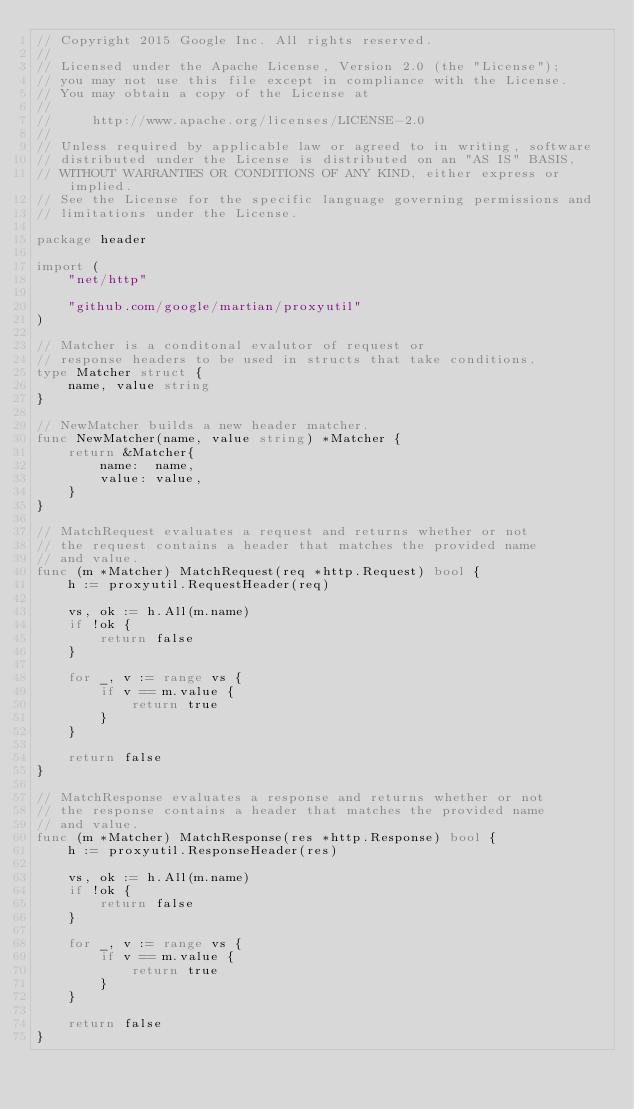<code> <loc_0><loc_0><loc_500><loc_500><_Go_>// Copyright 2015 Google Inc. All rights reserved.
//
// Licensed under the Apache License, Version 2.0 (the "License");
// you may not use this file except in compliance with the License.
// You may obtain a copy of the License at
//
//     http://www.apache.org/licenses/LICENSE-2.0
//
// Unless required by applicable law or agreed to in writing, software
// distributed under the License is distributed on an "AS IS" BASIS,
// WITHOUT WARRANTIES OR CONDITIONS OF ANY KIND, either express or implied.
// See the License for the specific language governing permissions and
// limitations under the License.

package header

import (
	"net/http"

	"github.com/google/martian/proxyutil"
)

// Matcher is a conditonal evalutor of request or
// response headers to be used in structs that take conditions.
type Matcher struct {
	name, value string
}

// NewMatcher builds a new header matcher.
func NewMatcher(name, value string) *Matcher {
	return &Matcher{
		name:  name,
		value: value,
	}
}

// MatchRequest evaluates a request and returns whether or not
// the request contains a header that matches the provided name
// and value.
func (m *Matcher) MatchRequest(req *http.Request) bool {
	h := proxyutil.RequestHeader(req)

	vs, ok := h.All(m.name)
	if !ok {
		return false
	}

	for _, v := range vs {
		if v == m.value {
			return true
		}
	}

	return false
}

// MatchResponse evaluates a response and returns whether or not
// the response contains a header that matches the provided name
// and value.
func (m *Matcher) MatchResponse(res *http.Response) bool {
	h := proxyutil.ResponseHeader(res)

	vs, ok := h.All(m.name)
	if !ok {
		return false
	}

	for _, v := range vs {
		if v == m.value {
			return true
		}
	}

	return false
}
</code> 